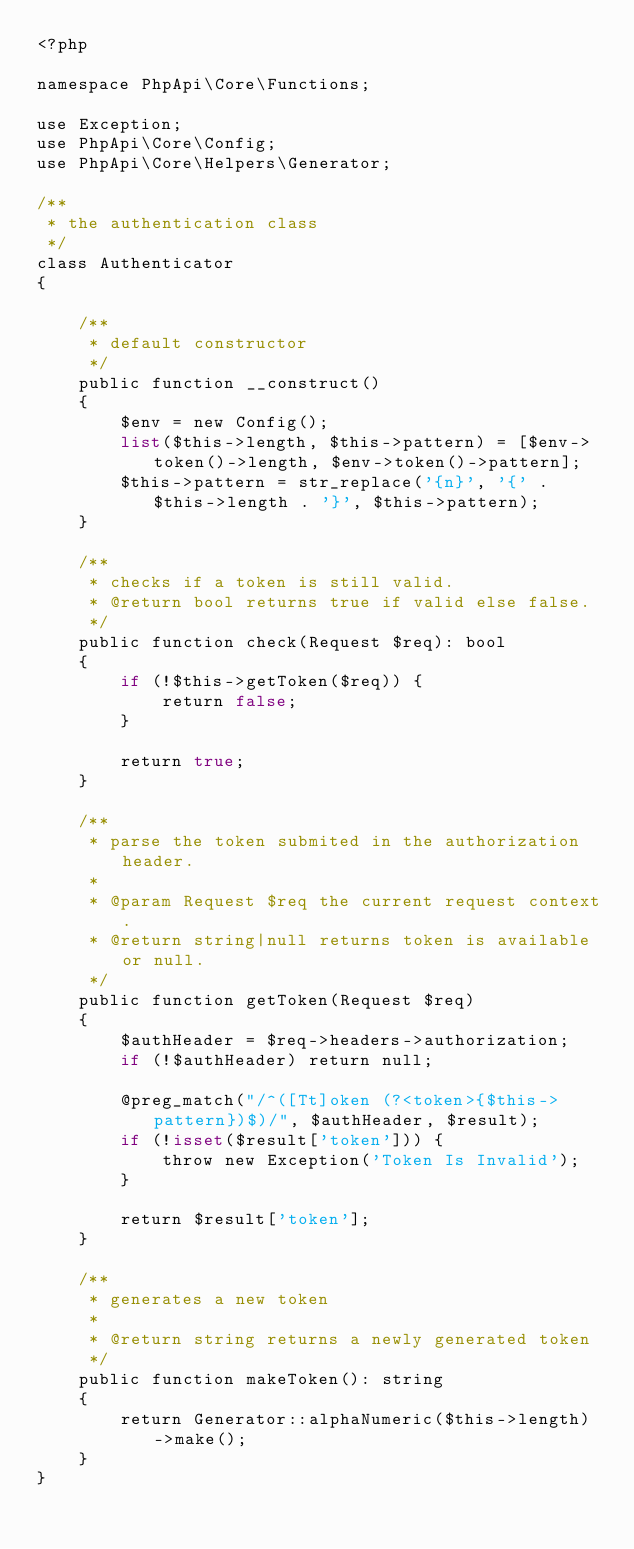Convert code to text. <code><loc_0><loc_0><loc_500><loc_500><_PHP_><?php

namespace PhpApi\Core\Functions;

use Exception;
use PhpApi\Core\Config;
use PhpApi\Core\Helpers\Generator;

/**
 * the authentication class
 */
class Authenticator
{

    /**
     * default constructor
     */
    public function __construct()
    {
        $env = new Config();
        list($this->length, $this->pattern) = [$env->token()->length, $env->token()->pattern];
        $this->pattern = str_replace('{n}', '{' . $this->length . '}', $this->pattern);
    }

    /**
     * checks if a token is still valid.
     * @return bool returns true if valid else false.
     */
    public function check(Request $req): bool
    {
        if (!$this->getToken($req)) {
            return false;
        }

        return true;
    }

    /**
     * parse the token submited in the authorization header.
     * 
     * @param Request $req the current request context.
     * @return string|null returns token is available or null. 
     */
    public function getToken(Request $req)
    {
        $authHeader = $req->headers->authorization;
        if (!$authHeader) return null;

        @preg_match("/^([Tt]oken (?<token>{$this->pattern})$)/", $authHeader, $result);
        if (!isset($result['token'])) {
            throw new Exception('Token Is Invalid');
        }

        return $result['token'];
    }

    /**
     * generates a new token
     * 
     * @return string returns a newly generated token
     */
    public function makeToken(): string
    {
        return Generator::alphaNumeric($this->length)->make();
    }
}
</code> 